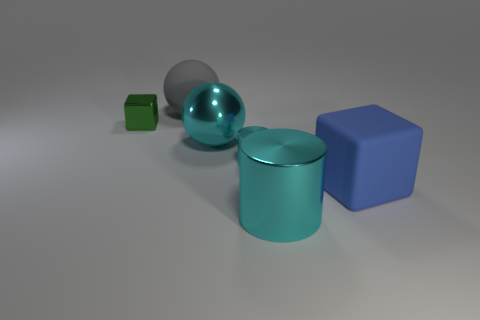How many other cylinders are the same color as the large cylinder?
Offer a very short reply. 1. How big is the shiny object on the left side of the ball that is behind the small green metal block?
Your answer should be very brief. Small. How many things are either large spheres that are behind the cyan ball or red rubber cubes?
Keep it short and to the point. 1. Are there any cyan shiny cylinders of the same size as the green block?
Keep it short and to the point. Yes. There is a block that is to the right of the matte sphere; are there any large metal spheres on the left side of it?
Offer a terse response. Yes. What number of balls are either big things or large gray matte things?
Make the answer very short. 2. Are there any other matte things of the same shape as the small green object?
Your answer should be compact. Yes. The blue matte object has what shape?
Give a very brief answer. Cube. How many things are large yellow rubber cylinders or green cubes?
Provide a short and direct response. 1. There is a cube right of the green object; does it have the same size as the ball in front of the gray rubber object?
Give a very brief answer. Yes. 